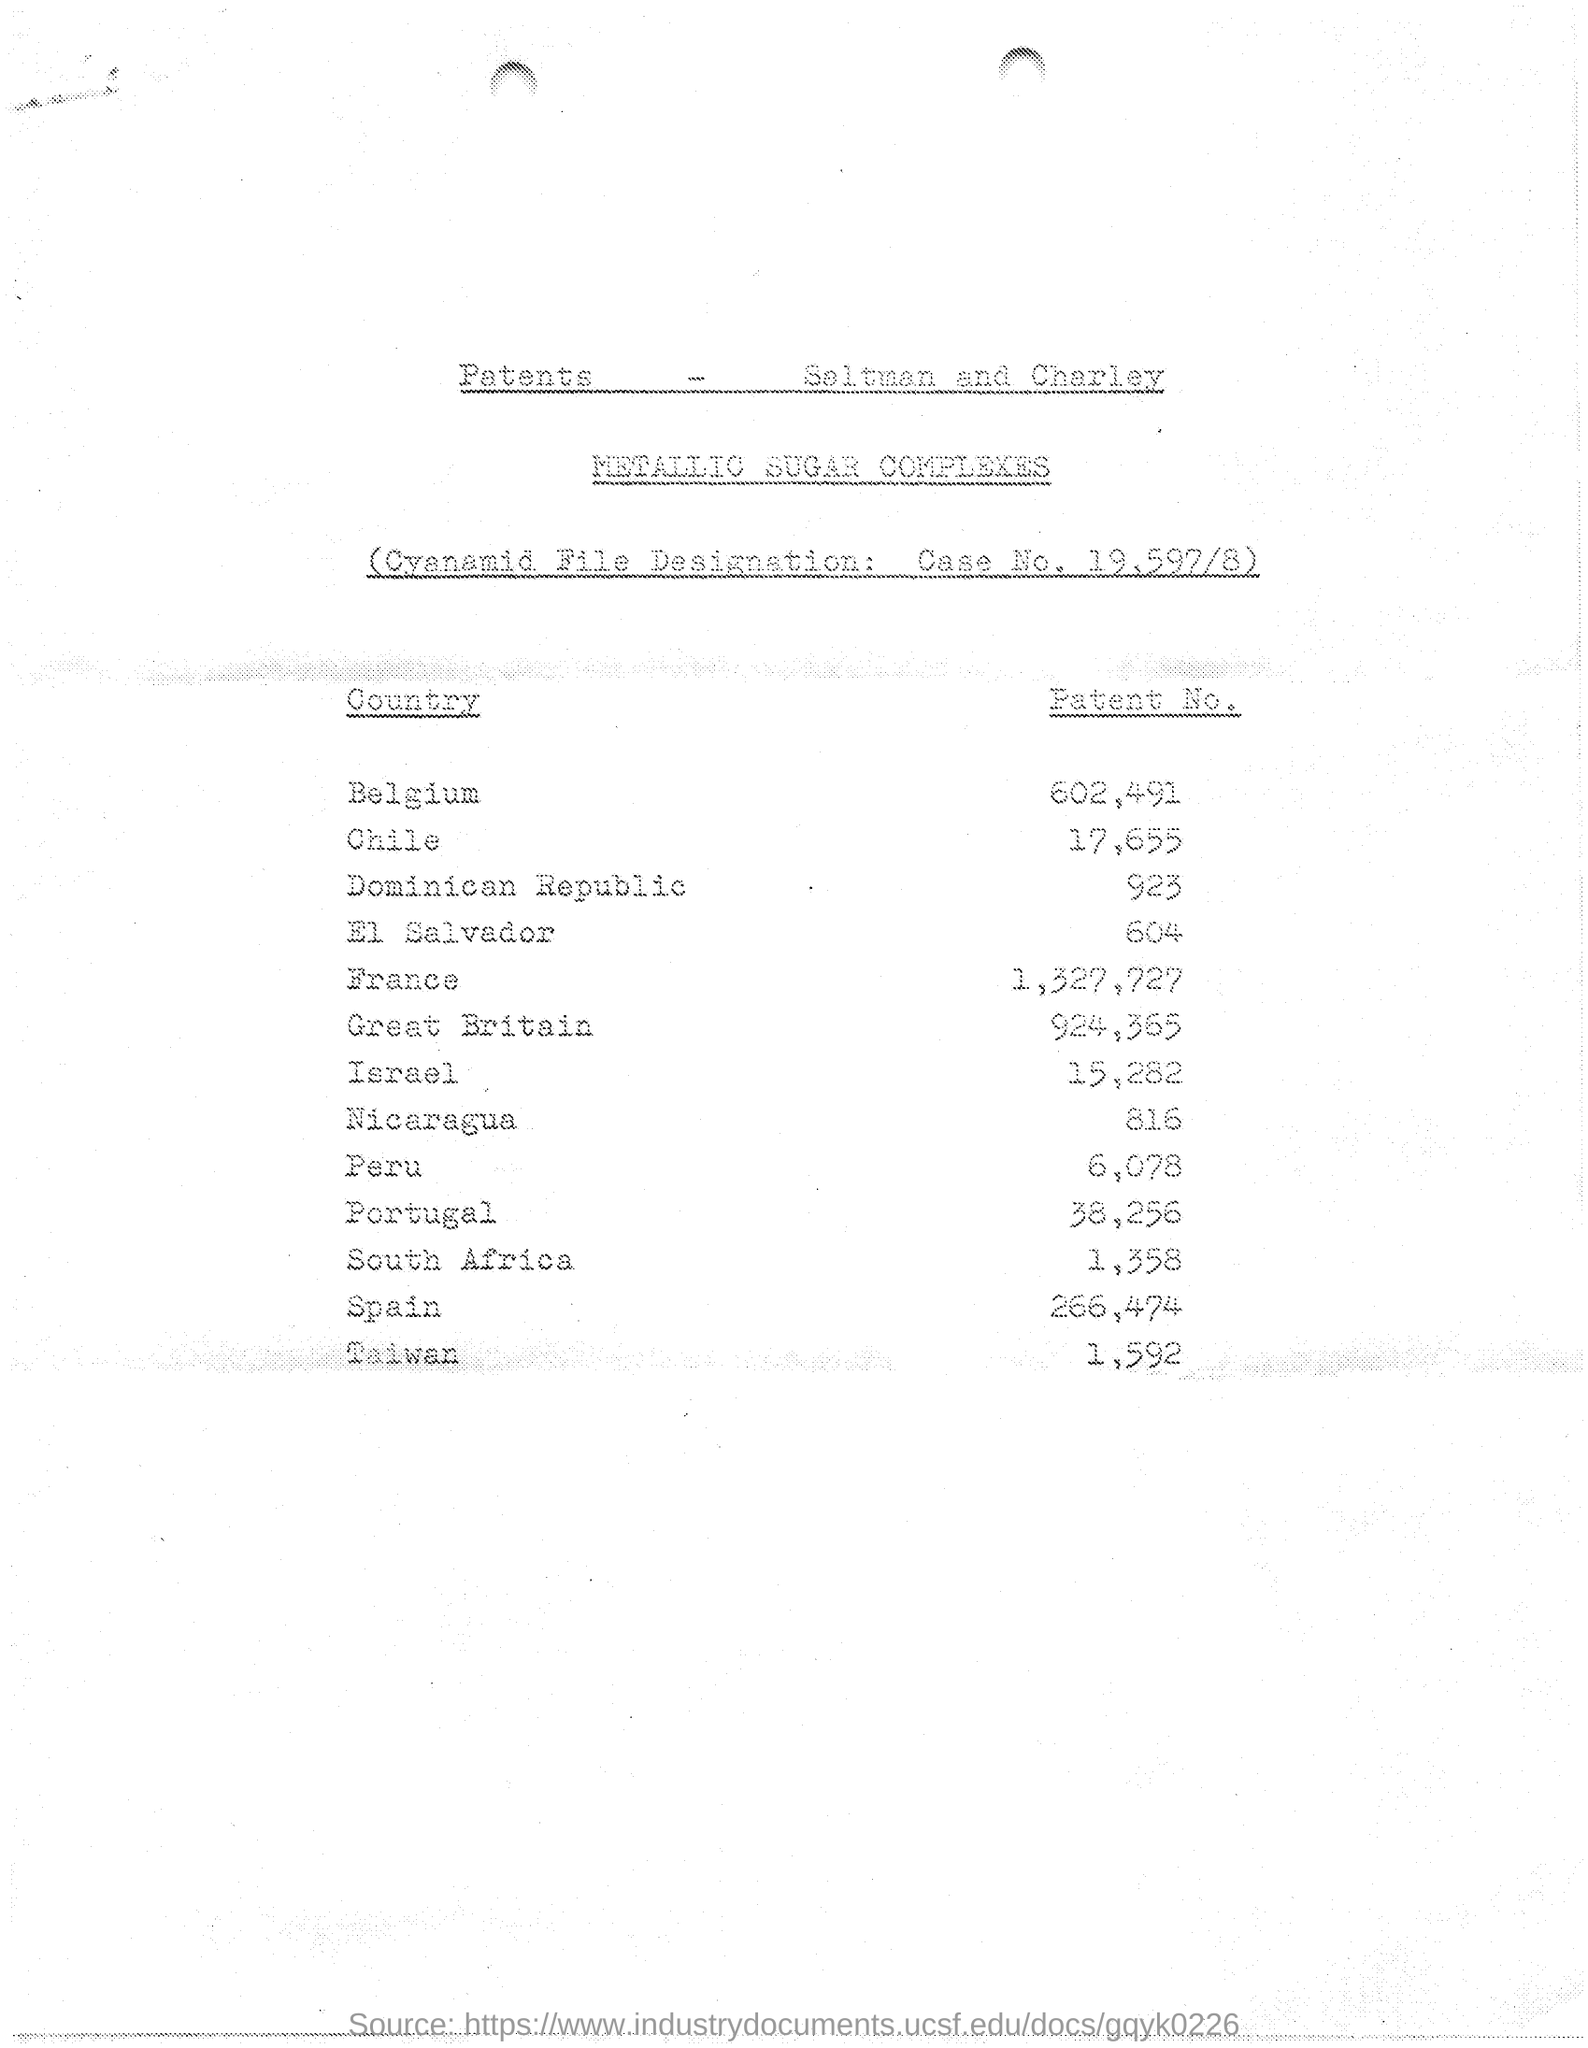List a handful of essential elements in this visual. As of 2021, Chile has registered 17,655 patents. There are approximately 602,491 patents in Belgium. According to the most recent data available, there were approximately 132,7727 patents granted in France as of the current date. 